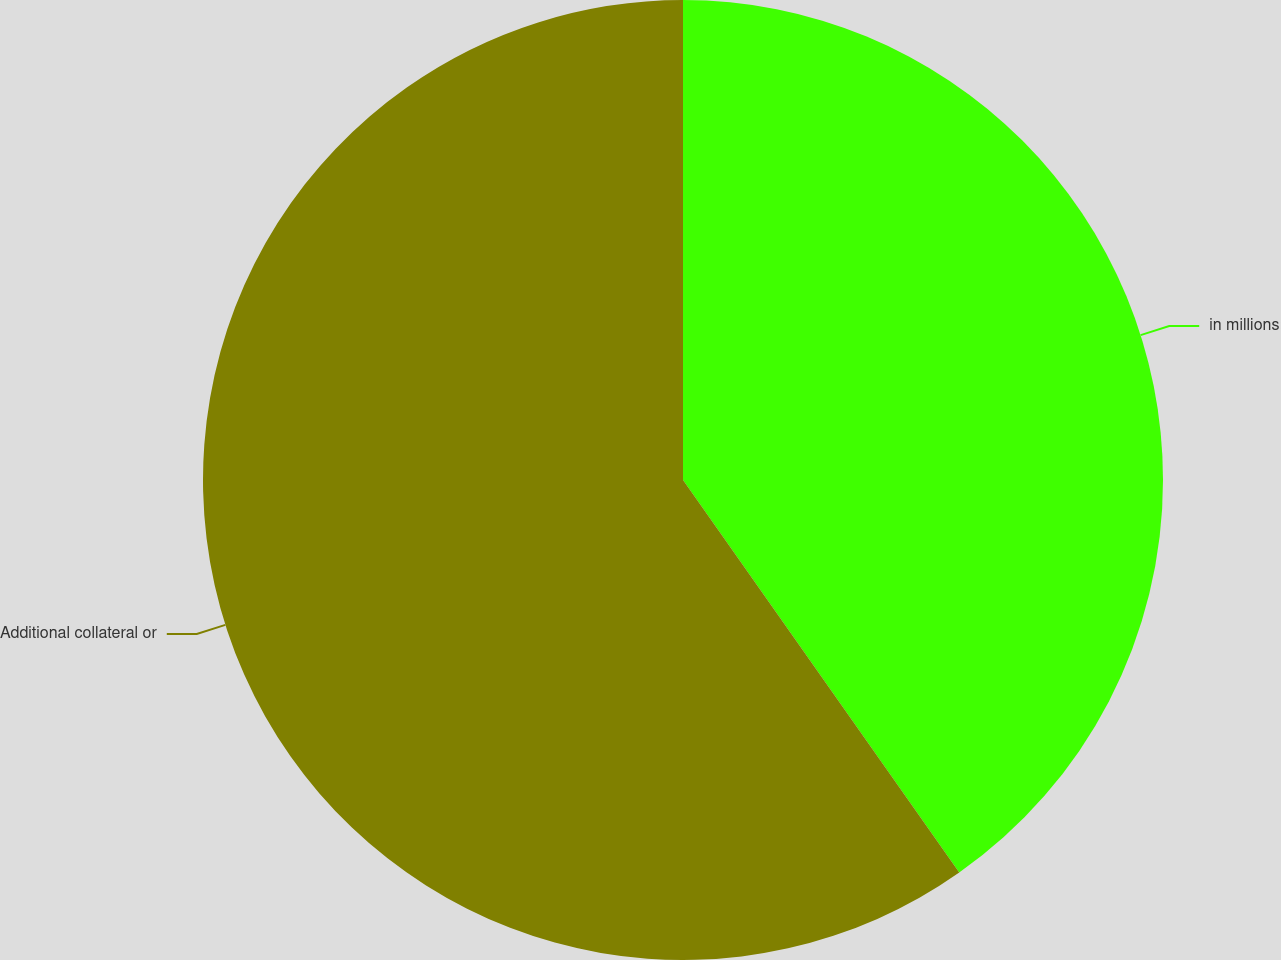Convert chart to OTSL. <chart><loc_0><loc_0><loc_500><loc_500><pie_chart><fcel>in millions<fcel>Additional collateral or<nl><fcel>40.24%<fcel>59.76%<nl></chart> 